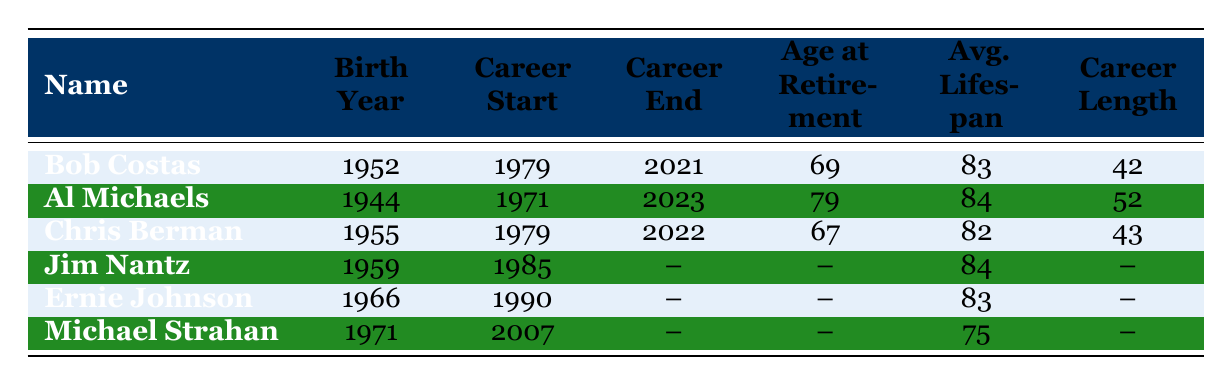What is the average lifespan of Bob Costas? Bob Costas has an average lifespan of 83 years, as indicated in the table under the "Avg. Lifespan" column next to his name.
Answer: 83 What year did Al Michaels start his career? Al Michaels began his career in 1971, which can be found in the "Career Start" column next to his name.
Answer: 1971 Is Jim Nantz's career still ongoing? Jim Nantz's career end year is listed as null, indicating he has not officially retired yet, so his career is still ongoing.
Answer: Yes Who had a longer career, Chris Berman or Ernie Johnson? Chris Berman's career length is indicated as 43 years (1979-2022), while Ernie Johnson has no recorded end year, making it impossible to determine his total career length based on the available data. Therefore, we can't directly compare the two.
Answer: Cannot determine What is the difference in average lifespan between Al Michaels and Michael Strahan? Al Michaels has an average lifespan of 84 years, while Michael Strahan has an average lifespan of 75 years. The difference is calculated by subtracting Strahan's lifespan from Michaels', giving us 84 - 75 = 9.
Answer: 9 How many commentators have an average lifespan above 82? Analyzing the table, the commentators with an average lifespan above 82 are Al Michaels (84), Jim Nantz (84), Ernie Johnson (83), and Bob Costas (83). Counting these names gives us a total of 4 commentators.
Answer: 4 Did any commentator retire at age 67? Yes, Chris Berman retired at age 67 as noted in the "Age at Retirement" column next to his name.
Answer: Yes What is the average age at retirement for the commentators listed? The ages at retirement for the commentators who have that information are 69, 79, 67, and potentially Jim Nantz and Ernie Johnson who are still active. The average can be calculated by summing the ages (69 + 79 + 67) = 215, and dividing by 3 gives us 215 / 3 = 71.67, which rounds to approximately 72.
Answer: 72 Which commentator has the longest career length? Al Michaels has the longest career length of 52 years, as his career started in 1971 and continues to the present year of 2023.
Answer: 52 